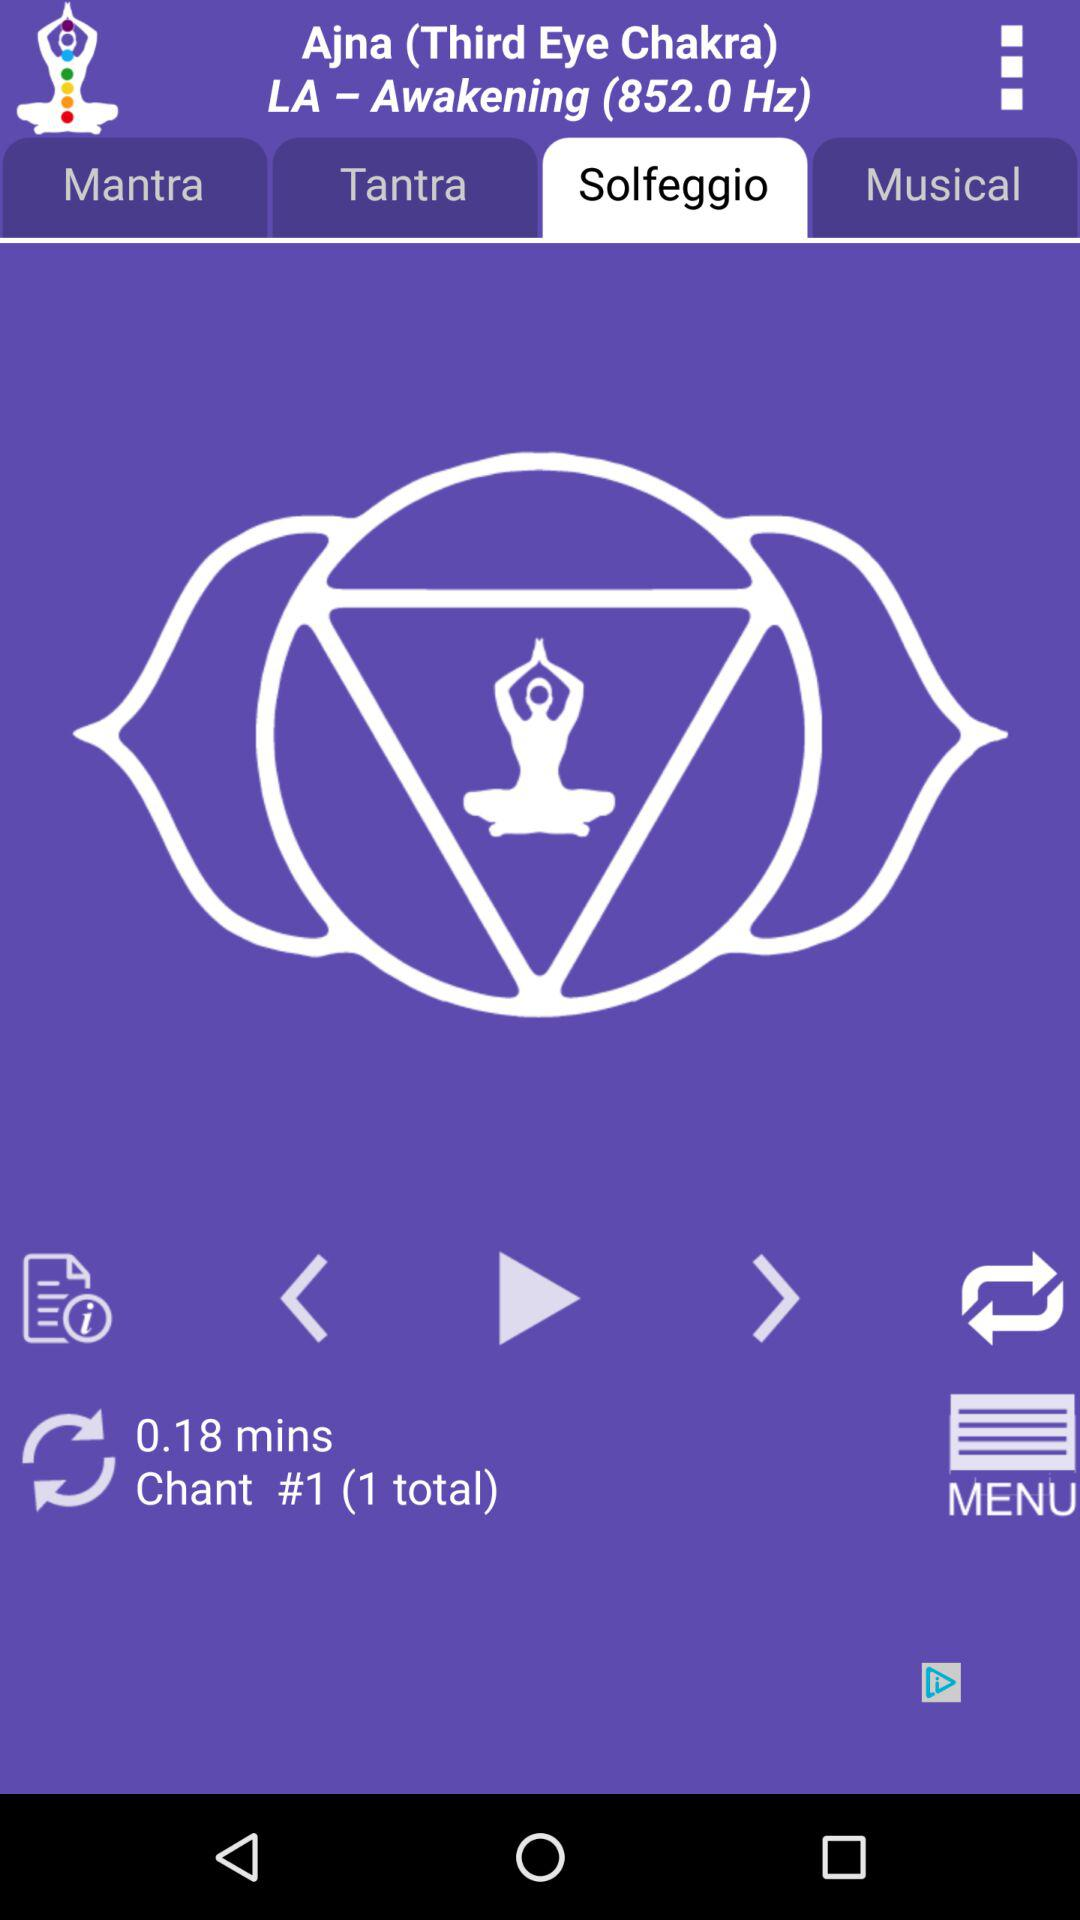Which tab has been selected? The selected tab is "Solfeggio". 